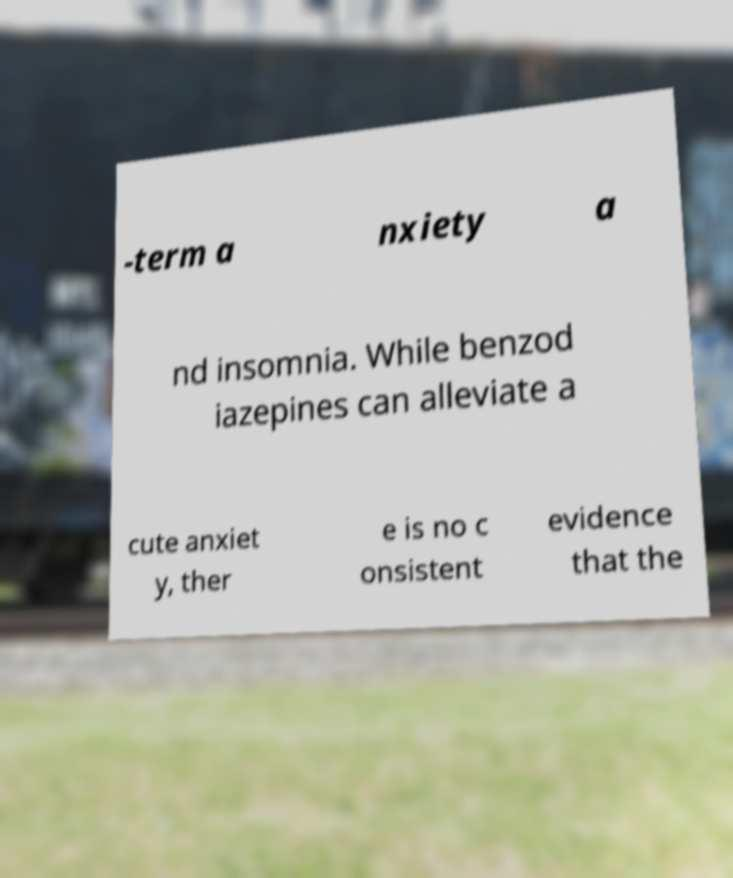What messages or text are displayed in this image? I need them in a readable, typed format. -term a nxiety a nd insomnia. While benzod iazepines can alleviate a cute anxiet y, ther e is no c onsistent evidence that the 